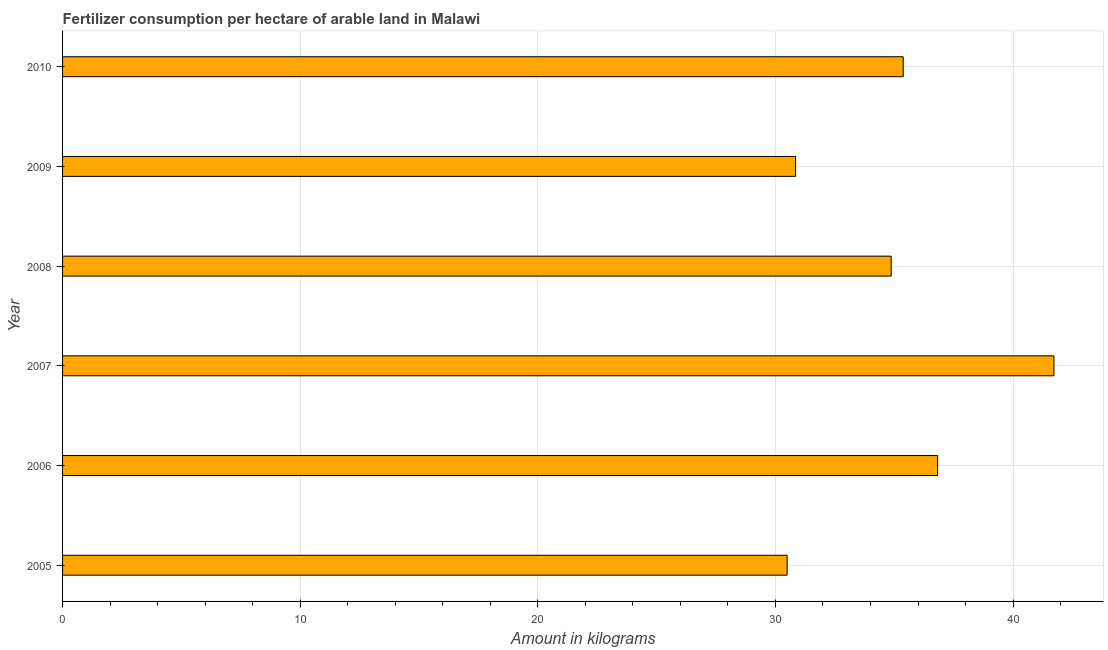What is the title of the graph?
Your response must be concise. Fertilizer consumption per hectare of arable land in Malawi . What is the label or title of the X-axis?
Your answer should be compact. Amount in kilograms. What is the amount of fertilizer consumption in 2006?
Your response must be concise. 36.82. Across all years, what is the maximum amount of fertilizer consumption?
Your answer should be very brief. 41.72. Across all years, what is the minimum amount of fertilizer consumption?
Give a very brief answer. 30.49. In which year was the amount of fertilizer consumption minimum?
Give a very brief answer. 2005. What is the sum of the amount of fertilizer consumption?
Provide a short and direct response. 210.13. What is the difference between the amount of fertilizer consumption in 2007 and 2009?
Provide a short and direct response. 10.87. What is the average amount of fertilizer consumption per year?
Offer a very short reply. 35.02. What is the median amount of fertilizer consumption?
Your response must be concise. 35.12. Do a majority of the years between 2009 and 2006 (inclusive) have amount of fertilizer consumption greater than 4 kg?
Offer a very short reply. Yes. What is the ratio of the amount of fertilizer consumption in 2007 to that in 2009?
Ensure brevity in your answer.  1.35. What is the difference between the highest and the second highest amount of fertilizer consumption?
Provide a short and direct response. 4.89. Is the sum of the amount of fertilizer consumption in 2007 and 2010 greater than the maximum amount of fertilizer consumption across all years?
Your response must be concise. Yes. What is the difference between the highest and the lowest amount of fertilizer consumption?
Keep it short and to the point. 11.23. Are all the bars in the graph horizontal?
Your response must be concise. Yes. How many years are there in the graph?
Offer a terse response. 6. What is the Amount in kilograms in 2005?
Provide a succinct answer. 30.49. What is the Amount in kilograms of 2006?
Provide a short and direct response. 36.82. What is the Amount in kilograms in 2007?
Give a very brief answer. 41.72. What is the Amount in kilograms of 2008?
Your answer should be compact. 34.87. What is the Amount in kilograms in 2009?
Your answer should be compact. 30.85. What is the Amount in kilograms of 2010?
Provide a succinct answer. 35.38. What is the difference between the Amount in kilograms in 2005 and 2006?
Offer a very short reply. -6.33. What is the difference between the Amount in kilograms in 2005 and 2007?
Your answer should be compact. -11.23. What is the difference between the Amount in kilograms in 2005 and 2008?
Ensure brevity in your answer.  -4.38. What is the difference between the Amount in kilograms in 2005 and 2009?
Keep it short and to the point. -0.35. What is the difference between the Amount in kilograms in 2005 and 2010?
Give a very brief answer. -4.88. What is the difference between the Amount in kilograms in 2006 and 2007?
Make the answer very short. -4.89. What is the difference between the Amount in kilograms in 2006 and 2008?
Your response must be concise. 1.95. What is the difference between the Amount in kilograms in 2006 and 2009?
Your answer should be compact. 5.98. What is the difference between the Amount in kilograms in 2006 and 2010?
Offer a very short reply. 1.45. What is the difference between the Amount in kilograms in 2007 and 2008?
Make the answer very short. 6.85. What is the difference between the Amount in kilograms in 2007 and 2009?
Ensure brevity in your answer.  10.87. What is the difference between the Amount in kilograms in 2007 and 2010?
Make the answer very short. 6.34. What is the difference between the Amount in kilograms in 2008 and 2009?
Keep it short and to the point. 4.02. What is the difference between the Amount in kilograms in 2008 and 2010?
Make the answer very short. -0.51. What is the difference between the Amount in kilograms in 2009 and 2010?
Provide a short and direct response. -4.53. What is the ratio of the Amount in kilograms in 2005 to that in 2006?
Provide a succinct answer. 0.83. What is the ratio of the Amount in kilograms in 2005 to that in 2007?
Give a very brief answer. 0.73. What is the ratio of the Amount in kilograms in 2005 to that in 2008?
Offer a very short reply. 0.87. What is the ratio of the Amount in kilograms in 2005 to that in 2010?
Offer a very short reply. 0.86. What is the ratio of the Amount in kilograms in 2006 to that in 2007?
Your response must be concise. 0.88. What is the ratio of the Amount in kilograms in 2006 to that in 2008?
Ensure brevity in your answer.  1.06. What is the ratio of the Amount in kilograms in 2006 to that in 2009?
Give a very brief answer. 1.19. What is the ratio of the Amount in kilograms in 2006 to that in 2010?
Your answer should be compact. 1.04. What is the ratio of the Amount in kilograms in 2007 to that in 2008?
Offer a very short reply. 1.2. What is the ratio of the Amount in kilograms in 2007 to that in 2009?
Your answer should be very brief. 1.35. What is the ratio of the Amount in kilograms in 2007 to that in 2010?
Keep it short and to the point. 1.18. What is the ratio of the Amount in kilograms in 2008 to that in 2009?
Your response must be concise. 1.13. What is the ratio of the Amount in kilograms in 2008 to that in 2010?
Give a very brief answer. 0.99. What is the ratio of the Amount in kilograms in 2009 to that in 2010?
Your answer should be compact. 0.87. 